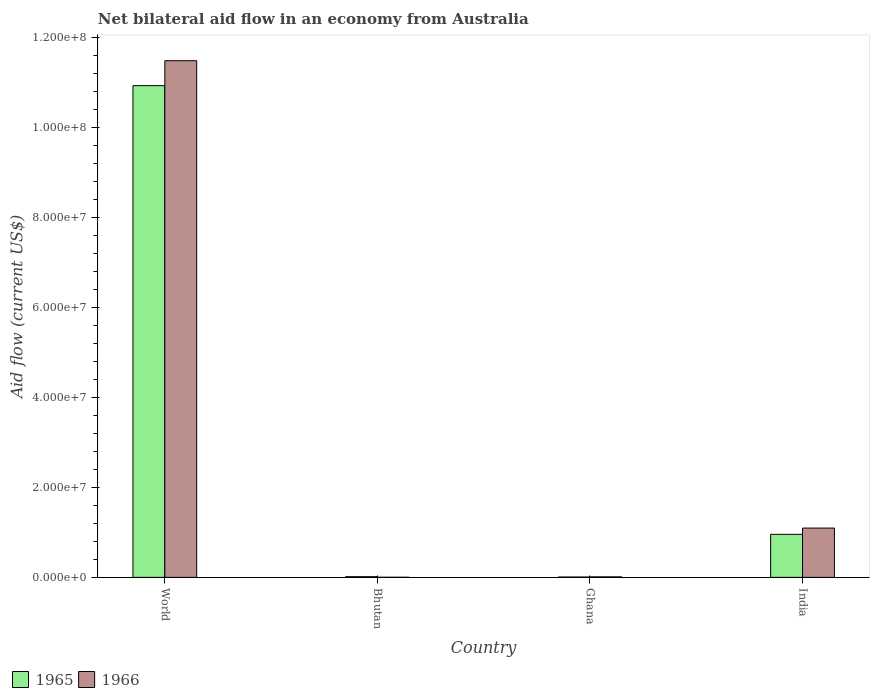How many groups of bars are there?
Your answer should be very brief. 4. Are the number of bars on each tick of the X-axis equal?
Offer a terse response. Yes. What is the label of the 2nd group of bars from the left?
Your answer should be very brief. Bhutan. What is the net bilateral aid flow in 1965 in Bhutan?
Your answer should be very brief. 1.50e+05. Across all countries, what is the maximum net bilateral aid flow in 1965?
Give a very brief answer. 1.09e+08. Across all countries, what is the minimum net bilateral aid flow in 1966?
Give a very brief answer. 2.00e+04. In which country was the net bilateral aid flow in 1965 maximum?
Give a very brief answer. World. In which country was the net bilateral aid flow in 1966 minimum?
Offer a terse response. Bhutan. What is the total net bilateral aid flow in 1966 in the graph?
Make the answer very short. 1.26e+08. What is the difference between the net bilateral aid flow in 1966 in Ghana and that in World?
Provide a short and direct response. -1.15e+08. What is the difference between the net bilateral aid flow in 1966 in Ghana and the net bilateral aid flow in 1965 in World?
Your response must be concise. -1.09e+08. What is the average net bilateral aid flow in 1965 per country?
Provide a succinct answer. 2.98e+07. What is the ratio of the net bilateral aid flow in 1965 in Ghana to that in India?
Provide a succinct answer. 0.01. Is the net bilateral aid flow in 1965 in India less than that in World?
Make the answer very short. Yes. Is the difference between the net bilateral aid flow in 1966 in India and World greater than the difference between the net bilateral aid flow in 1965 in India and World?
Provide a short and direct response. No. What is the difference between the highest and the second highest net bilateral aid flow in 1965?
Your answer should be very brief. 1.09e+08. What is the difference between the highest and the lowest net bilateral aid flow in 1965?
Keep it short and to the point. 1.09e+08. In how many countries, is the net bilateral aid flow in 1966 greater than the average net bilateral aid flow in 1966 taken over all countries?
Offer a very short reply. 1. Is the sum of the net bilateral aid flow in 1965 in Bhutan and Ghana greater than the maximum net bilateral aid flow in 1966 across all countries?
Your response must be concise. No. What does the 2nd bar from the left in Bhutan represents?
Your answer should be compact. 1966. What does the 2nd bar from the right in India represents?
Your answer should be compact. 1965. How many bars are there?
Provide a short and direct response. 8. Are the values on the major ticks of Y-axis written in scientific E-notation?
Offer a very short reply. Yes. How many legend labels are there?
Keep it short and to the point. 2. What is the title of the graph?
Offer a terse response. Net bilateral aid flow in an economy from Australia. What is the Aid flow (current US$) of 1965 in World?
Give a very brief answer. 1.09e+08. What is the Aid flow (current US$) in 1966 in World?
Your answer should be compact. 1.15e+08. What is the Aid flow (current US$) of 1965 in Bhutan?
Give a very brief answer. 1.50e+05. What is the Aid flow (current US$) of 1966 in Ghana?
Provide a short and direct response. 1.10e+05. What is the Aid flow (current US$) in 1965 in India?
Give a very brief answer. 9.56e+06. What is the Aid flow (current US$) of 1966 in India?
Ensure brevity in your answer.  1.10e+07. Across all countries, what is the maximum Aid flow (current US$) of 1965?
Keep it short and to the point. 1.09e+08. Across all countries, what is the maximum Aid flow (current US$) in 1966?
Offer a very short reply. 1.15e+08. Across all countries, what is the minimum Aid flow (current US$) in 1965?
Make the answer very short. 7.00e+04. Across all countries, what is the minimum Aid flow (current US$) in 1966?
Keep it short and to the point. 2.00e+04. What is the total Aid flow (current US$) in 1965 in the graph?
Provide a succinct answer. 1.19e+08. What is the total Aid flow (current US$) in 1966 in the graph?
Offer a terse response. 1.26e+08. What is the difference between the Aid flow (current US$) in 1965 in World and that in Bhutan?
Your answer should be very brief. 1.09e+08. What is the difference between the Aid flow (current US$) of 1966 in World and that in Bhutan?
Provide a short and direct response. 1.15e+08. What is the difference between the Aid flow (current US$) in 1965 in World and that in Ghana?
Give a very brief answer. 1.09e+08. What is the difference between the Aid flow (current US$) of 1966 in World and that in Ghana?
Your answer should be very brief. 1.15e+08. What is the difference between the Aid flow (current US$) of 1965 in World and that in India?
Provide a short and direct response. 9.97e+07. What is the difference between the Aid flow (current US$) of 1966 in World and that in India?
Give a very brief answer. 1.04e+08. What is the difference between the Aid flow (current US$) of 1965 in Bhutan and that in Ghana?
Offer a terse response. 8.00e+04. What is the difference between the Aid flow (current US$) of 1965 in Bhutan and that in India?
Provide a succinct answer. -9.41e+06. What is the difference between the Aid flow (current US$) in 1966 in Bhutan and that in India?
Offer a very short reply. -1.09e+07. What is the difference between the Aid flow (current US$) in 1965 in Ghana and that in India?
Offer a terse response. -9.49e+06. What is the difference between the Aid flow (current US$) in 1966 in Ghana and that in India?
Make the answer very short. -1.08e+07. What is the difference between the Aid flow (current US$) in 1965 in World and the Aid flow (current US$) in 1966 in Bhutan?
Offer a very short reply. 1.09e+08. What is the difference between the Aid flow (current US$) of 1965 in World and the Aid flow (current US$) of 1966 in Ghana?
Give a very brief answer. 1.09e+08. What is the difference between the Aid flow (current US$) in 1965 in World and the Aid flow (current US$) in 1966 in India?
Provide a short and direct response. 9.83e+07. What is the difference between the Aid flow (current US$) in 1965 in Bhutan and the Aid flow (current US$) in 1966 in India?
Make the answer very short. -1.08e+07. What is the difference between the Aid flow (current US$) of 1965 in Ghana and the Aid flow (current US$) of 1966 in India?
Ensure brevity in your answer.  -1.09e+07. What is the average Aid flow (current US$) of 1965 per country?
Provide a succinct answer. 2.98e+07. What is the average Aid flow (current US$) of 1966 per country?
Your response must be concise. 3.15e+07. What is the difference between the Aid flow (current US$) in 1965 and Aid flow (current US$) in 1966 in World?
Your answer should be very brief. -5.54e+06. What is the difference between the Aid flow (current US$) in 1965 and Aid flow (current US$) in 1966 in India?
Ensure brevity in your answer.  -1.39e+06. What is the ratio of the Aid flow (current US$) of 1965 in World to that in Bhutan?
Your answer should be very brief. 728.33. What is the ratio of the Aid flow (current US$) of 1966 in World to that in Bhutan?
Your answer should be compact. 5739.5. What is the ratio of the Aid flow (current US$) in 1965 in World to that in Ghana?
Keep it short and to the point. 1560.71. What is the ratio of the Aid flow (current US$) in 1966 in World to that in Ghana?
Offer a terse response. 1043.55. What is the ratio of the Aid flow (current US$) in 1965 in World to that in India?
Make the answer very short. 11.43. What is the ratio of the Aid flow (current US$) of 1966 in World to that in India?
Your answer should be very brief. 10.48. What is the ratio of the Aid flow (current US$) in 1965 in Bhutan to that in Ghana?
Your response must be concise. 2.14. What is the ratio of the Aid flow (current US$) of 1966 in Bhutan to that in Ghana?
Your answer should be very brief. 0.18. What is the ratio of the Aid flow (current US$) in 1965 in Bhutan to that in India?
Offer a terse response. 0.02. What is the ratio of the Aid flow (current US$) in 1966 in Bhutan to that in India?
Ensure brevity in your answer.  0. What is the ratio of the Aid flow (current US$) of 1965 in Ghana to that in India?
Provide a succinct answer. 0.01. What is the ratio of the Aid flow (current US$) in 1966 in Ghana to that in India?
Give a very brief answer. 0.01. What is the difference between the highest and the second highest Aid flow (current US$) of 1965?
Ensure brevity in your answer.  9.97e+07. What is the difference between the highest and the second highest Aid flow (current US$) of 1966?
Offer a terse response. 1.04e+08. What is the difference between the highest and the lowest Aid flow (current US$) of 1965?
Make the answer very short. 1.09e+08. What is the difference between the highest and the lowest Aid flow (current US$) in 1966?
Your response must be concise. 1.15e+08. 